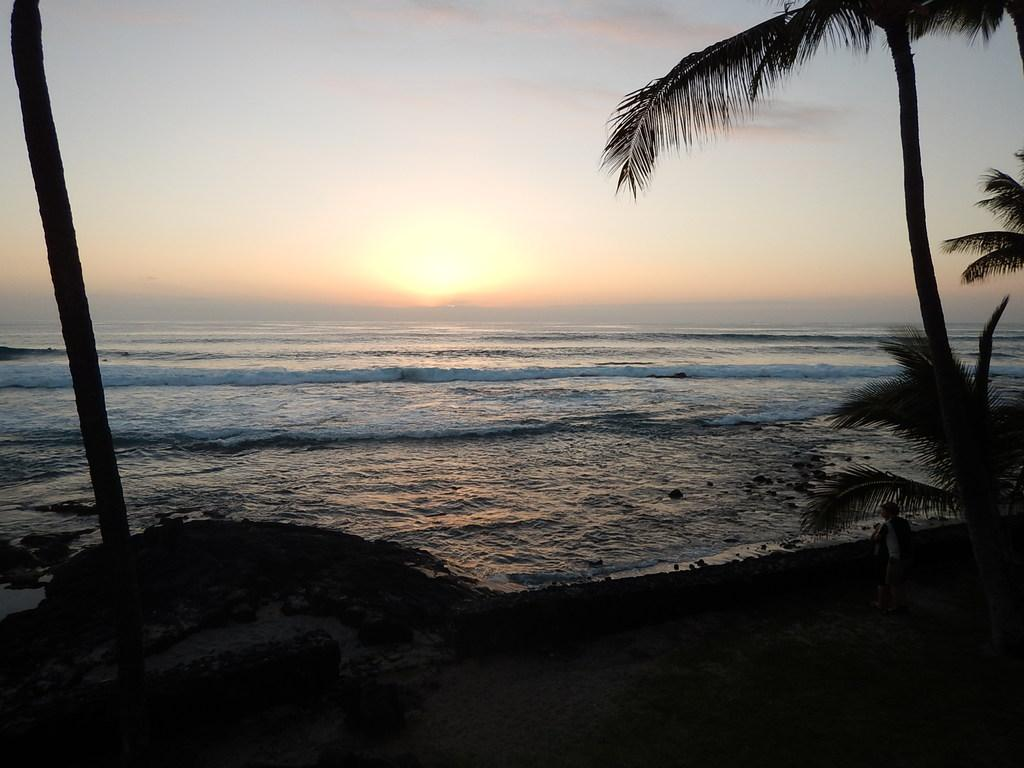Who or what is present in the image? There are people in the image. What type of natural environment can be seen in the image? There are trees and water visible in the image. What is visible in the background of the image? The sun and sky are visible in the background. How many chickens are visible in the image? There are no chickens present in the image. What things are sparking in the image? There are no things sparking in the image. 